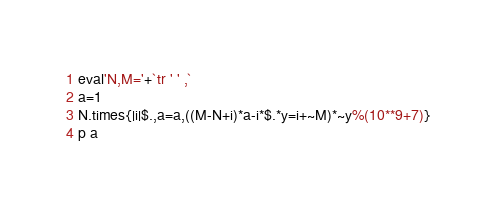Convert code to text. <code><loc_0><loc_0><loc_500><loc_500><_Ruby_>eval'N,M='+`tr ' ' ,`
a=1
N.times{|i|$.,a=a,((M-N+i)*a-i*$.*y=i+~M)*~y%(10**9+7)}
p a</code> 